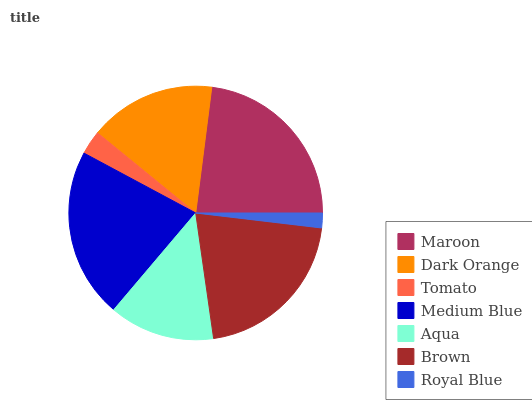Is Royal Blue the minimum?
Answer yes or no. Yes. Is Maroon the maximum?
Answer yes or no. Yes. Is Dark Orange the minimum?
Answer yes or no. No. Is Dark Orange the maximum?
Answer yes or no. No. Is Maroon greater than Dark Orange?
Answer yes or no. Yes. Is Dark Orange less than Maroon?
Answer yes or no. Yes. Is Dark Orange greater than Maroon?
Answer yes or no. No. Is Maroon less than Dark Orange?
Answer yes or no. No. Is Dark Orange the high median?
Answer yes or no. Yes. Is Dark Orange the low median?
Answer yes or no. Yes. Is Royal Blue the high median?
Answer yes or no. No. Is Aqua the low median?
Answer yes or no. No. 